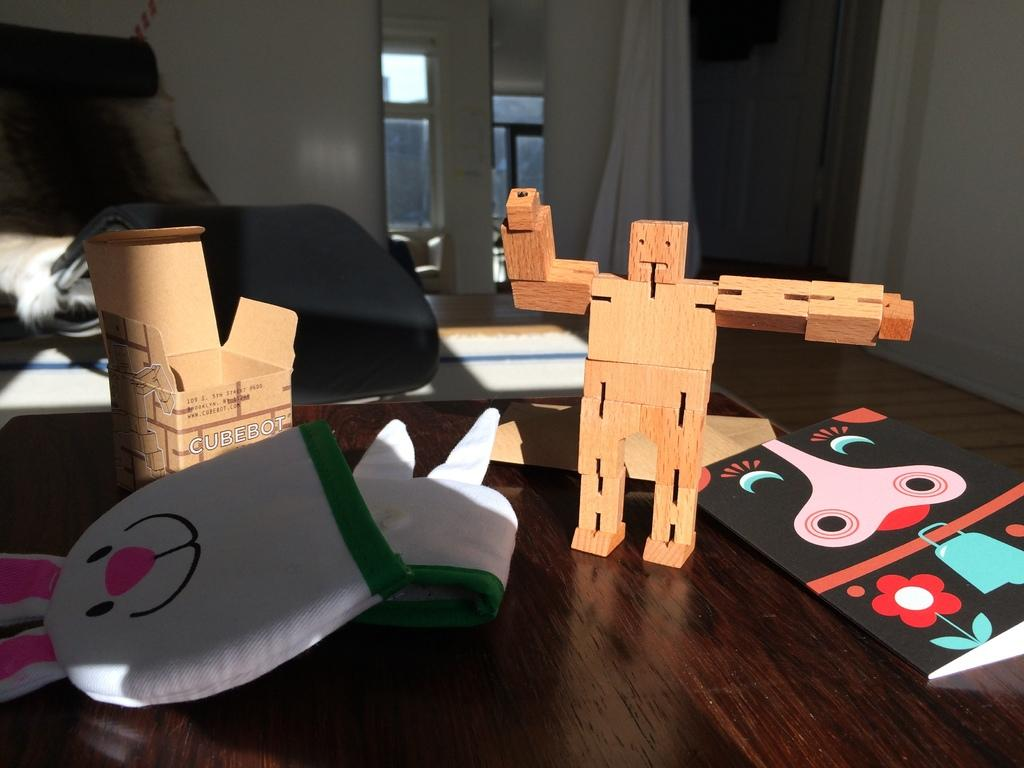<image>
Summarize the visual content of the image. a cubebot box that is next to a fake toy 